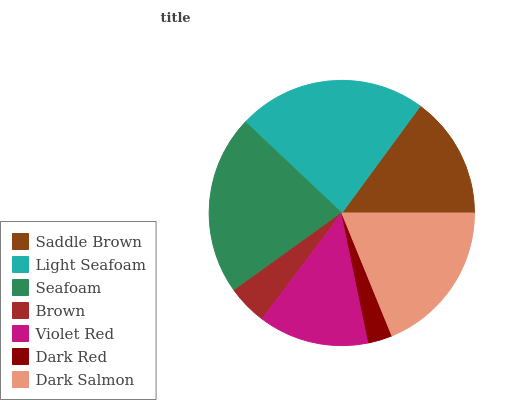Is Dark Red the minimum?
Answer yes or no. Yes. Is Light Seafoam the maximum?
Answer yes or no. Yes. Is Seafoam the minimum?
Answer yes or no. No. Is Seafoam the maximum?
Answer yes or no. No. Is Light Seafoam greater than Seafoam?
Answer yes or no. Yes. Is Seafoam less than Light Seafoam?
Answer yes or no. Yes. Is Seafoam greater than Light Seafoam?
Answer yes or no. No. Is Light Seafoam less than Seafoam?
Answer yes or no. No. Is Saddle Brown the high median?
Answer yes or no. Yes. Is Saddle Brown the low median?
Answer yes or no. Yes. Is Brown the high median?
Answer yes or no. No. Is Dark Red the low median?
Answer yes or no. No. 